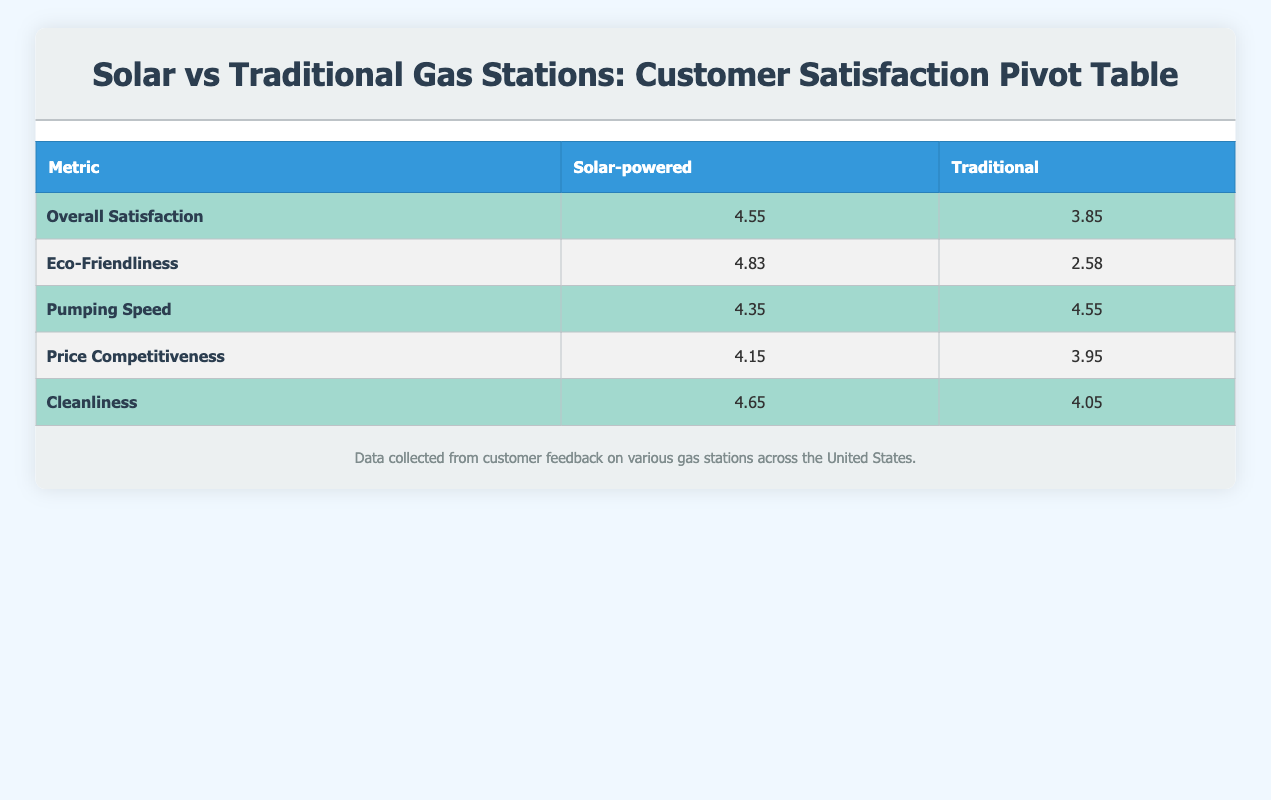What is the overall satisfaction rating for solar-powered gas stations? The table shows the average overall satisfaction rating for solar-powered stations, which is listed in the corresponding row under the "Solar-powered" column. This value is 4.55.
Answer: 4.55 What is the eco-friendliness rating for traditional gas stations? In the table, the eco-friendliness rating for traditional gas stations is found in the row labeled "Eco-Friendliness" under the "Traditional" column, which shows a value of 2.58.
Answer: 2.58 Which type of gas station has a higher average cleanliness rating? To determine this, we compare the average cleanliness ratings listed for both types of stations in their respective rows. The solar-powered stations have an average cleanliness rating of 4.65, while traditional stations have a rating of 4.05. Solar-powered stations are higher.
Answer: Solar-powered What is the difference in price competitiveness ratings between the two types of gas stations? The price competitiveness ratings are 4.15 for solar-powered stations and 3.95 for traditional stations. The difference is calculated as 4.15 - 3.95, which equals 0.20.
Answer: 0.20 Is the pumping speed for solar-powered gas stations higher than for traditional ones? The pumping speed for solar-powered stations is recorded as 4.35, whereas for traditional stations it is 4.55. Since 4.35 is less than 4.55, the statement is false.
Answer: No Which station type has lower average ratings in eco-friendliness and overall satisfaction? From the table, we see that traditional gas stations have lower ratings: eco-friendliness is 2.58 and overall satisfaction is 3.85. Therefore, traditional gas stations have lower averages for both metrics.
Answer: Traditional What is the average rating for pumping speed across all gas stations? To find this, we need to sum the pumping speeds: (4.5 + 4.7 + 4.3 + 4.6 + 4.4 + 4.5 + 4.2 + 4.4) = 34.2. There are 8 stations, so we divide 34.2 by 8 to get 34.2 / 8 = 4.275.
Answer: 4.28 Are there any solar-powered stations with an overall satisfaction rating above 4.5? Reviewing the overall satisfaction ratings for solar-powered stations, we see values of 4.7, 4.5, and 4.6. Since all these values are above 4.5, the answer is yes.
Answer: Yes What is the average eco-friendliness rating for all gas stations? Summing the eco-friendliness ratings: (4.9 + 2.5 + 4.8 + 2.8 + 4.9 + 2.6 + 4.7 + 2.4) = 25.6, and dividing by the number of stations (8) gives us an average of 25.6 / 8 = 3.20.
Answer: 3.20 